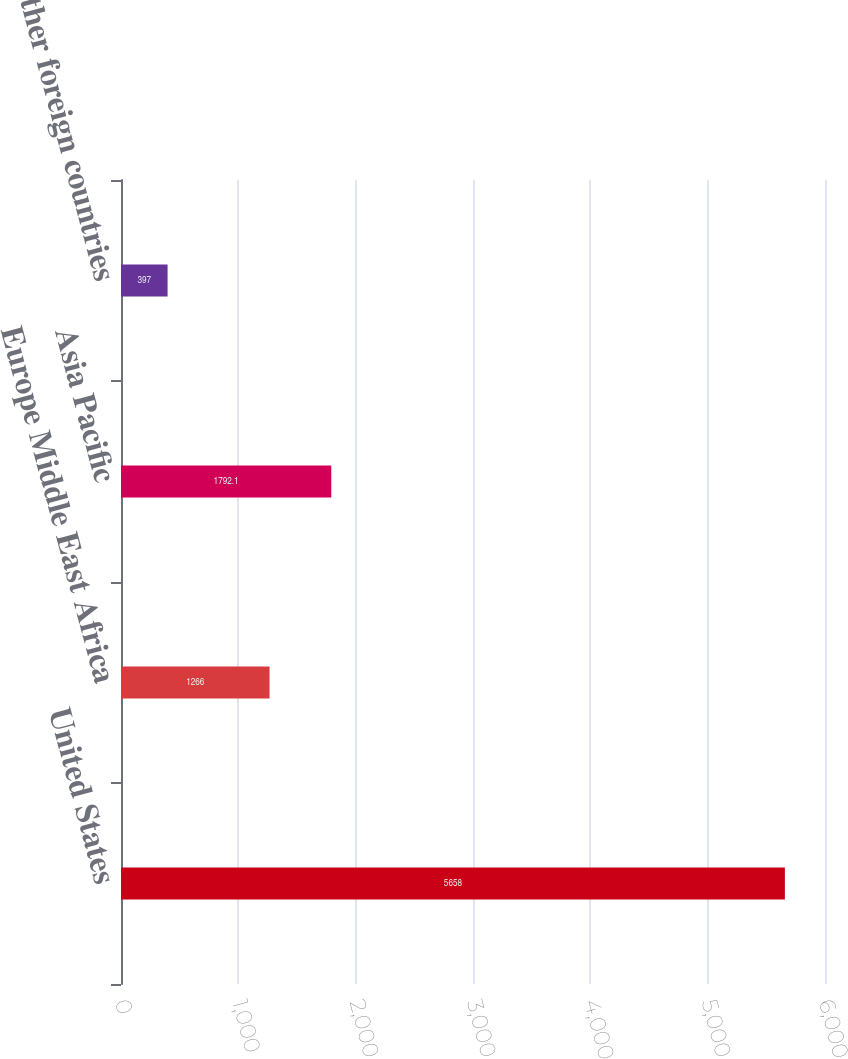Convert chart to OTSL. <chart><loc_0><loc_0><loc_500><loc_500><bar_chart><fcel>United States<fcel>Europe Middle East Africa<fcel>Asia Pacific<fcel>Other foreign countries<nl><fcel>5658<fcel>1266<fcel>1792.1<fcel>397<nl></chart> 